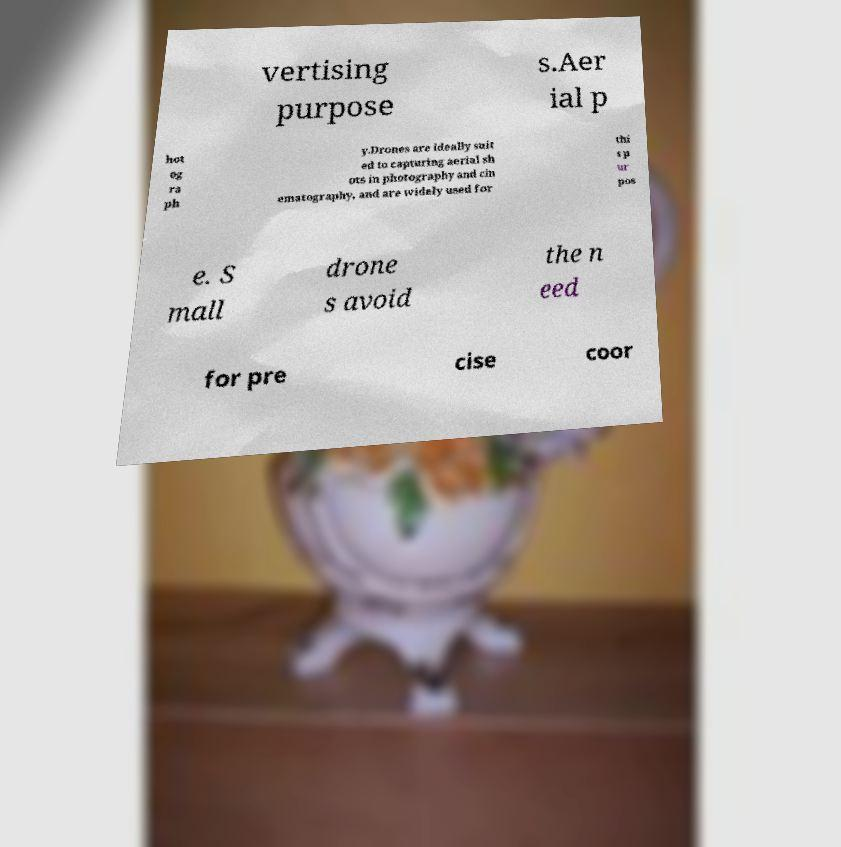Please identify and transcribe the text found in this image. vertising purpose s.Aer ial p hot og ra ph y.Drones are ideally suit ed to capturing aerial sh ots in photography and cin ematography, and are widely used for thi s p ur pos e. S mall drone s avoid the n eed for pre cise coor 